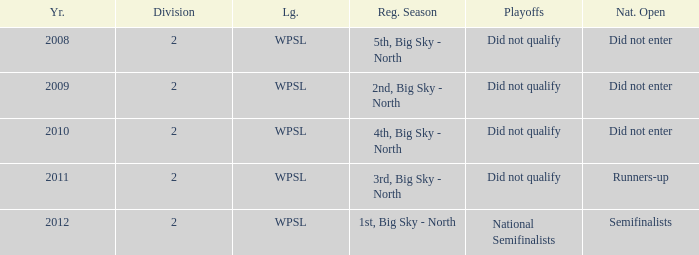What was the regular season name where they did not qualify for the playoffs in 2009? 2nd, Big Sky - North. 